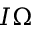Convert formula to latex. <formula><loc_0><loc_0><loc_500><loc_500>I { \boldsymbol \Omega }</formula> 